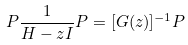<formula> <loc_0><loc_0><loc_500><loc_500>P \frac { 1 } { H - z I } P = [ G ( z ) ] ^ { - 1 } P</formula> 